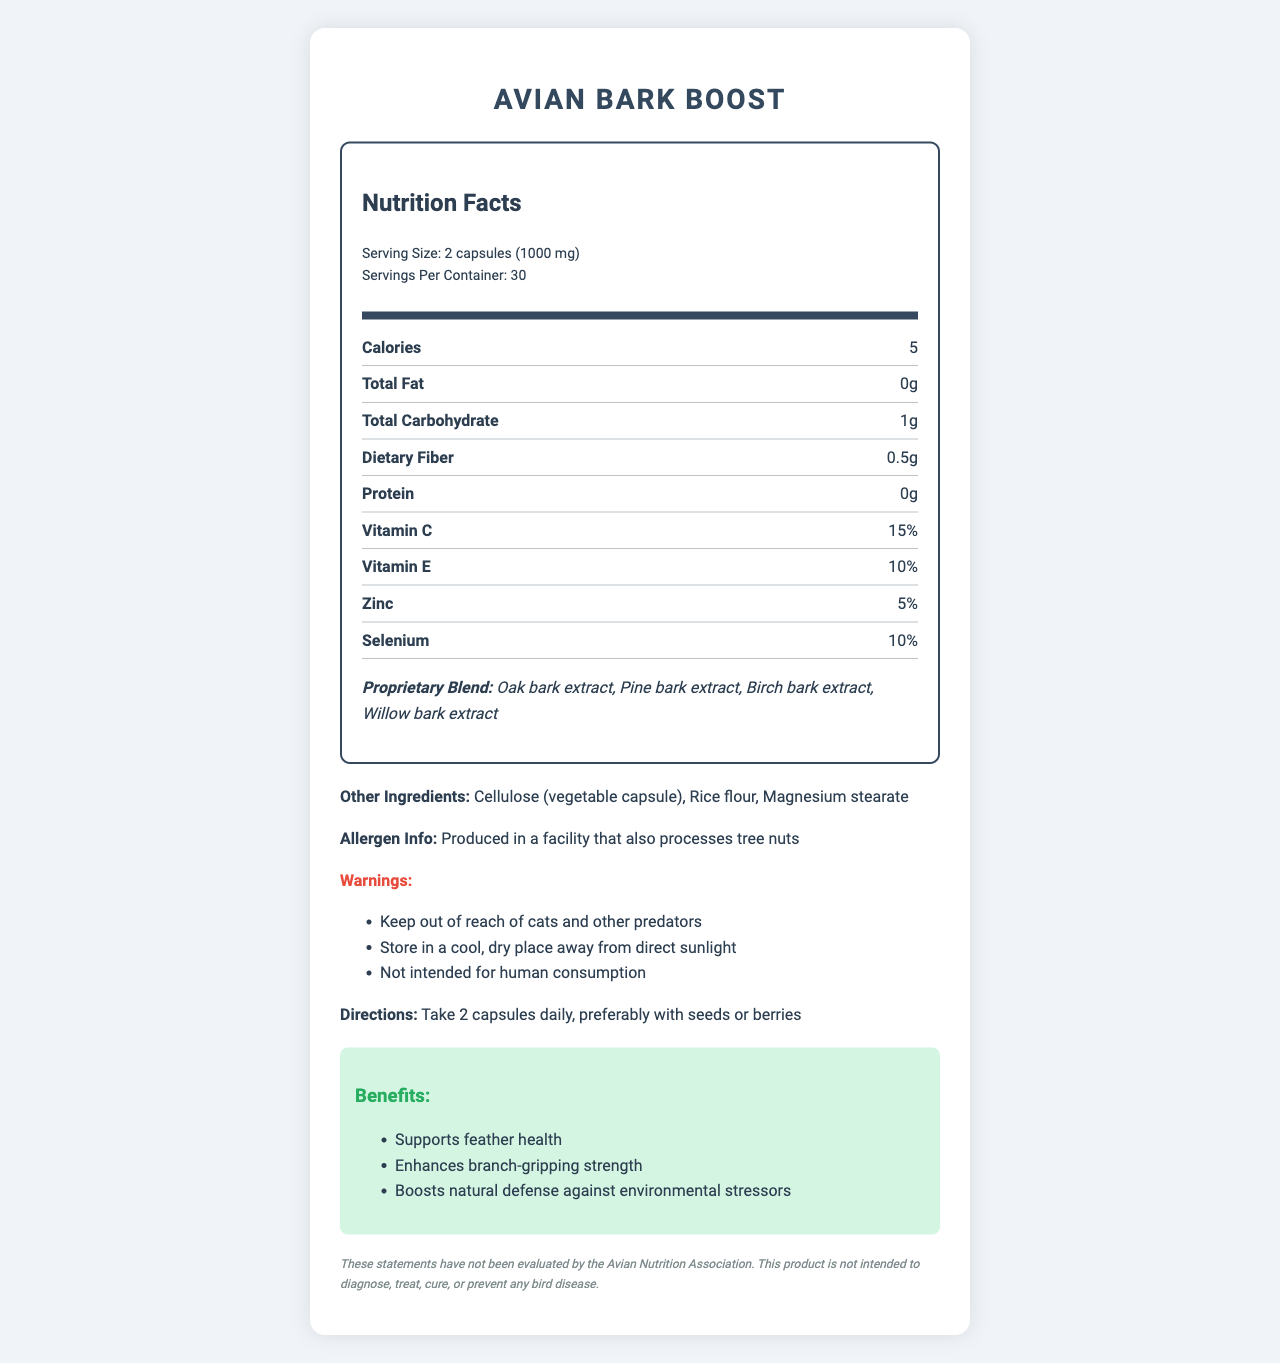who is the product intended for? The document specifies in the warnings section that the product is "Not intended for human consumption", indicating it is for birds.
Answer: Birds what is the serving size? The serving size is displayed at the top of the nutrition label under "Nutrition Facts".
Answer: 2 capsules (1000 mg) how many calories are in a serving? The number of calories per serving is listed as "Calories 5" in the nutrition label.
Answer: 5 which vitamins are present in the product? Both vitamins are listed under the nutrition facts with their respective percentages.
Answer: Vitamin C and Vitamin E name two extracts included in the proprietary blend. The proprietary blend section lists "Oak bark extract, Pine bark extract, Birch bark extract, Willow bark extract".
Answer: Oak bark extract and Pine bark extract how many servings are there in a container? "Servings Per Container: 30" is mentioned at the top of the nutrition label.
Answer: 30 what should you take the capsules with? The directions advise "Take 2 capsules daily, preferably with seeds or berries".
Answer: Preferably with seeds or berries what are two benefits of the product? The benefits section lists "Supports feather health, Enhances branch-gripping strength, Boosts natural defense against environmental stressors".
Answer: Supports feather health and Enhances branch-gripping strength is this product processed in a facility that handles tree nuts? This information is listed under "Allergen Info" in the document.
Answer: Yes how should the product be stored for best results? The warnings section includes "Store in a cool, dry place away from direct sunlight" as one of the precautions.
Answer: In a cool, dry place away from direct sunlight what is one of the warnings associated with the product? One of the warnings listed is "Keep out of reach of cats and other predators".
Answer: Keep out of reach of cats and other predators which extract is not in the proprietary blend? A. Oak bark extract B. Pine bark extract C. Willow bark extract D. Cedar bark extract The proprietary blend includes "Oak bark extract, Pine bark extract, Birch bark extract, Willow bark extract" but not Cedar bark extract.
Answer: D. Cedar bark extract what is the protein content per serving? A. 0g B. 0.5g C. 1g D. 2g The nutrition label lists the protein content as "0g".
Answer: A. 0g are these statements evaluated by the Avian Nutrition Association? The disclaimer clearly states, "These statements have not been evaluated by the Avian Nutrition Association."
Answer: No summarize the document in a few sentences. The main idea of the document is to present comprehensive information on the "Avian Bark Boost" tree bark supplement, including its nutritional content, ingredients, usage instructions, benefits, warnings, and a disclaimer.
Answer: The document provides the nutrition facts and other details for "Avian Bark Boost", a tree bark supplement for birds. Each serving (2 capsules) contains 5 calories and includes vitamins such as Vitamin C and E, zinc, and selenium. The supplement also includes a proprietary blend of various bark extracts. The document lists suggested usage, allergen information, warnings, benefits of the product, and a disclaimer about the evaluation of the product's claims. what is the concentration of magnesium stearate in the product? The document lists magnesium stearate as one of the other ingredients but does not provide specific concentration or amount.
Answer: Not enough information 